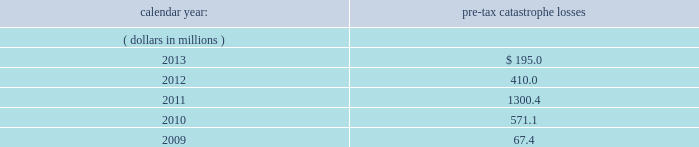Corporate income taxes other than withholding taxes on certain investment income and premium excise taxes .
If group or its bermuda subsidiaries were to become subject to u.s .
Income tax , there could be a material adverse effect on the company 2019s financial condition , results of operations and cash flows .
United kingdom .
Bermuda re 2019s uk branch conducts business in the uk and is subject to taxation in the uk .
Bermuda re believes that it has operated and will continue to operate its bermuda operation in a manner which will not cause them to be subject to uk taxation .
If bermuda re 2019s bermuda operations were to become subject to uk income tax , there could be a material adverse impact on the company 2019s financial condition , results of operations and cash flow .
Ireland .
Holdings ireland and ireland re conduct business in ireland and are subject to taxation in ireland .
Available information .
The company 2019s annual reports on form 10-k , quarterly reports on form 10-q , current reports on form 8- k , proxy statements and amendments to those reports are available free of charge through the company 2019s internet website at http://www.everestregroup.com as soon as reasonably practicable after such reports are electronically filed with the securities and exchange commission ( the 201csec 201d ) .
Item 1a .
Risk factors in addition to the other information provided in this report , the following risk factors should be considered when evaluating an investment in our securities .
If the circumstances contemplated by the individual risk factors materialize , our business , financial condition and results of operations could be materially and adversely affected and the trading price of our common shares could decline significantly .
Risks relating to our business fluctuations in the financial markets could result in investment losses .
Prolonged and severe disruptions in the public debt and equity markets , such as occurred during 2008 , could result in significant realized and unrealized losses in our investment portfolio .
Although financial markets have significantly improved since 2008 , they could deteriorate in the future .
Such declines in the financial markets could result in significant realized and unrealized losses on investments and could have a material adverse impact on our results of operations , equity , business and insurer financial strength and debt ratings .
Our results could be adversely affected by catastrophic events .
We are exposed to unpredictable catastrophic events , including weather-related and other natural catastrophes , as well as acts of terrorism .
Any material reduction in our operating results caused by the occurrence of one or more catastrophes could inhibit our ability to pay dividends or to meet our interest and principal payment obligations .
Subsequent to april 1 , 2010 , we define a catastrophe as an event that causes a loss on property exposures before reinsurance of at least $ 10.0 million , before corporate level reinsurance and taxes .
Prior to april 1 , 2010 , we used a threshold of $ 5.0 million .
By way of illustration , during the past five calendar years , pre-tax catastrophe losses , net of contract specific reinsurance but before cessions under corporate reinsurance programs , were as follows: .

What are the total pre-tax catastrophe losses in the last two years? 
Computations: (195.0 + 410.0)
Answer: 605.0. 